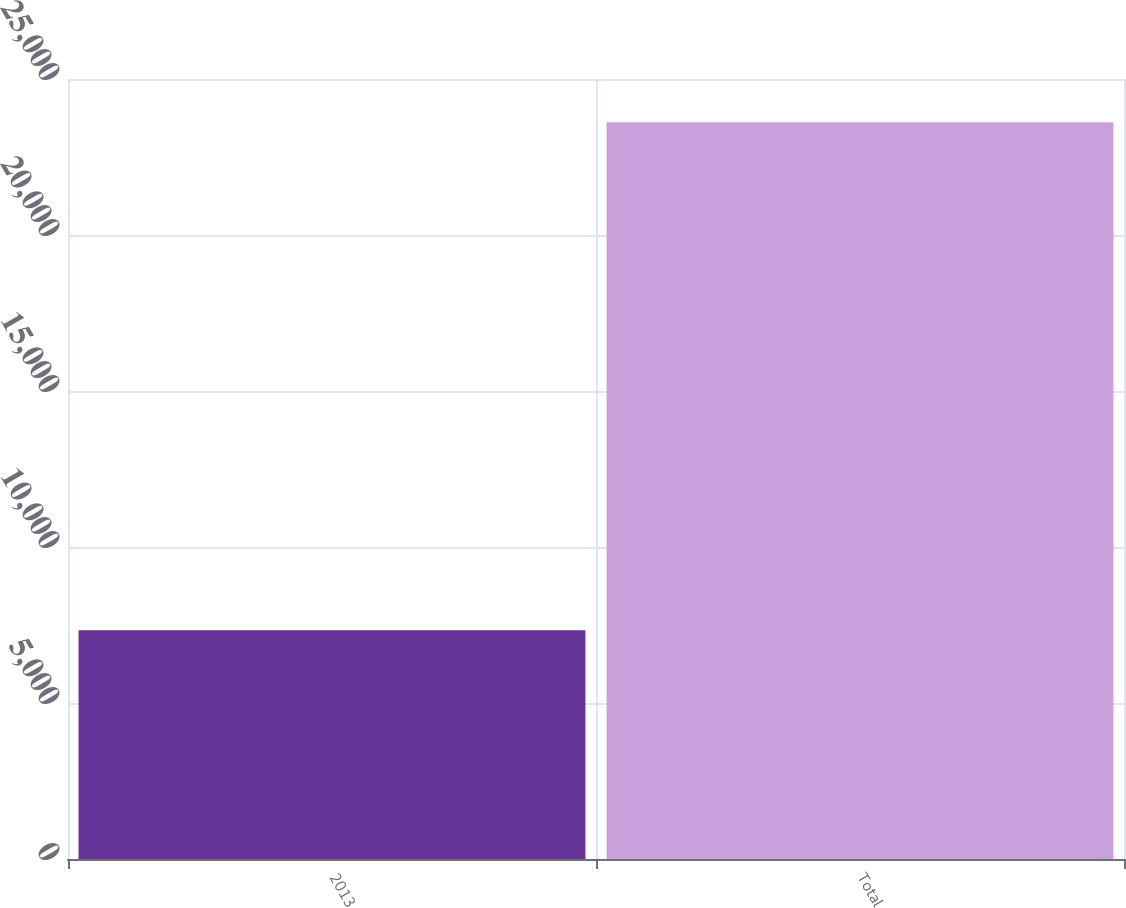Convert chart to OTSL. <chart><loc_0><loc_0><loc_500><loc_500><bar_chart><fcel>2013<fcel>Total<nl><fcel>7331<fcel>23615<nl></chart> 